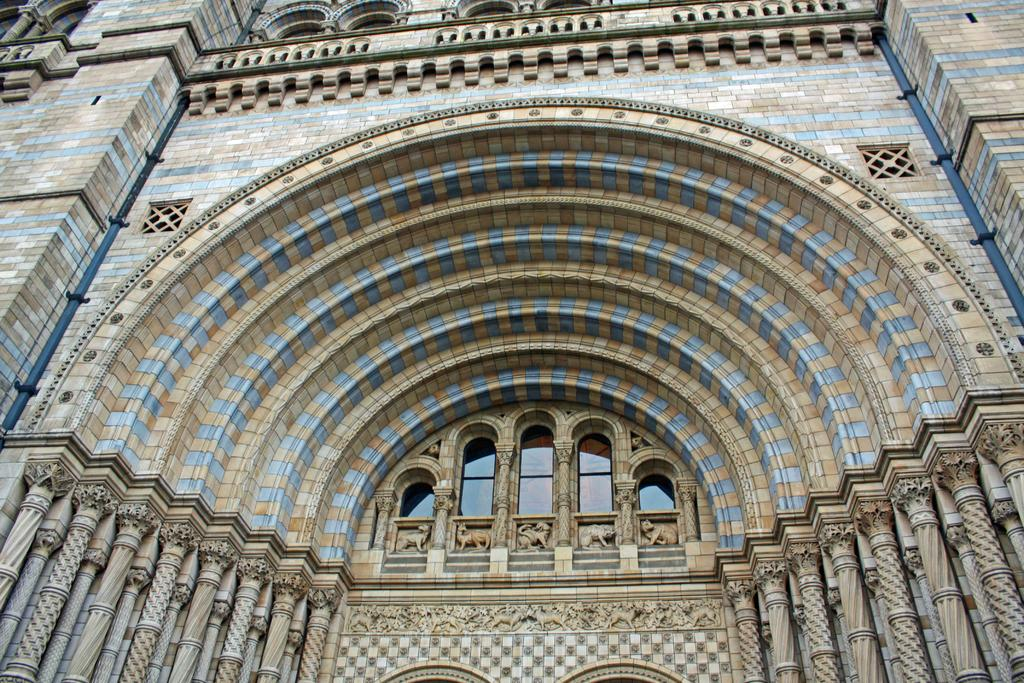What is the main subject of the image? The main subject of the image is a building. How is the building positioned in the image? The image shows the front view of the building. What type of windows does the building have? The building has glass windows. Can you see a map on the wall inside the building in the image? There is no indication of a map or any interior details of the building in the image, as it only shows the front view. 